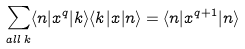Convert formula to latex. <formula><loc_0><loc_0><loc_500><loc_500>\sum _ { a l l \, k } \langle n | x ^ { q } | k \rangle \langle k | x | n \rangle = \langle n | x ^ { q + 1 } | n \rangle</formula> 